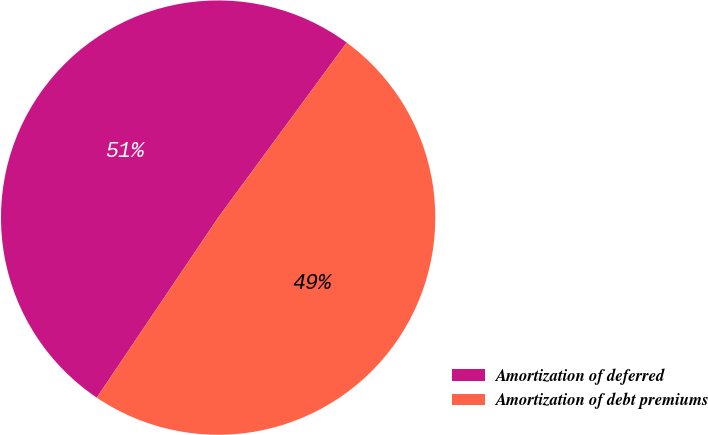<chart> <loc_0><loc_0><loc_500><loc_500><pie_chart><fcel>Amortization of deferred<fcel>Amortization of debt premiums<nl><fcel>50.64%<fcel>49.36%<nl></chart> 